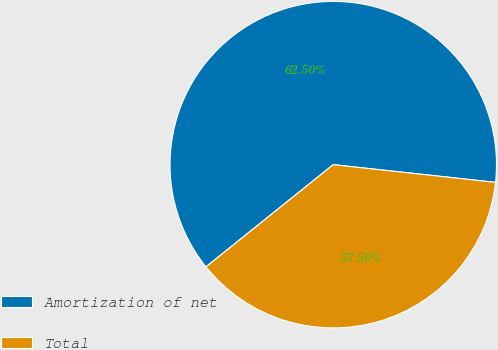Convert chart to OTSL. <chart><loc_0><loc_0><loc_500><loc_500><pie_chart><fcel>Amortization of net<fcel>Total<nl><fcel>62.5%<fcel>37.5%<nl></chart> 